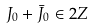<formula> <loc_0><loc_0><loc_500><loc_500>J _ { 0 } + \bar { J } _ { 0 } \in 2 Z</formula> 